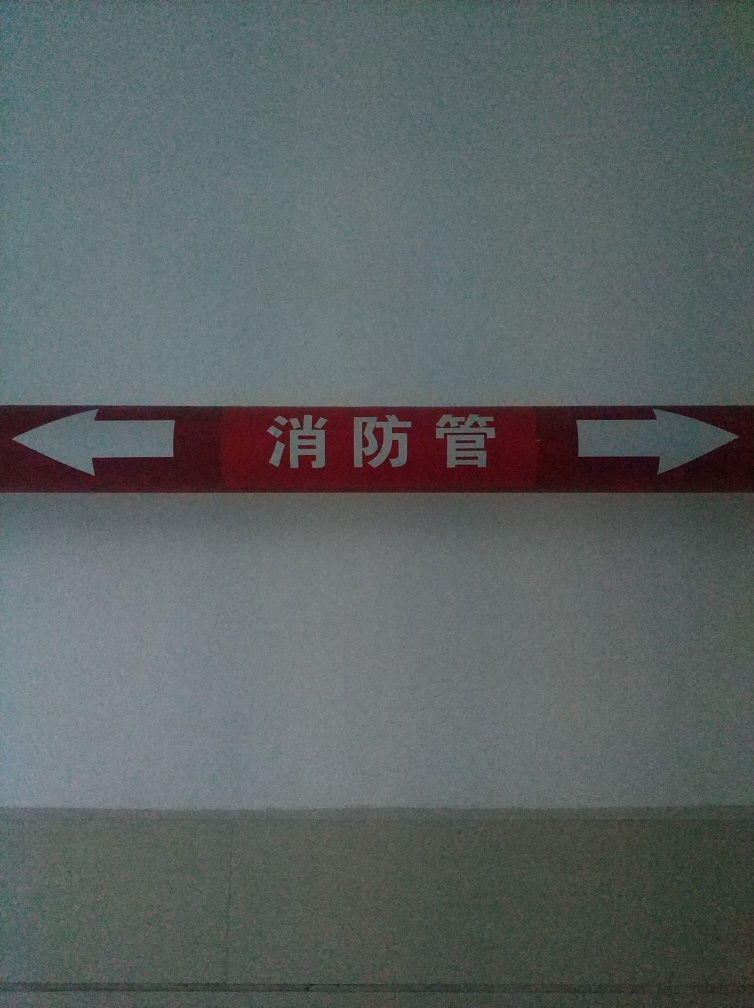Is the background of the image clear?
A. Yes
B. Detailed
C. Sharp
D. No
Answer with the option's letter from the given choices directly. The background of the image is not clear, exhibiting a uniform appearance with no distinguishing details or sharp features to observe. It presents a flat, non-descript texture. 